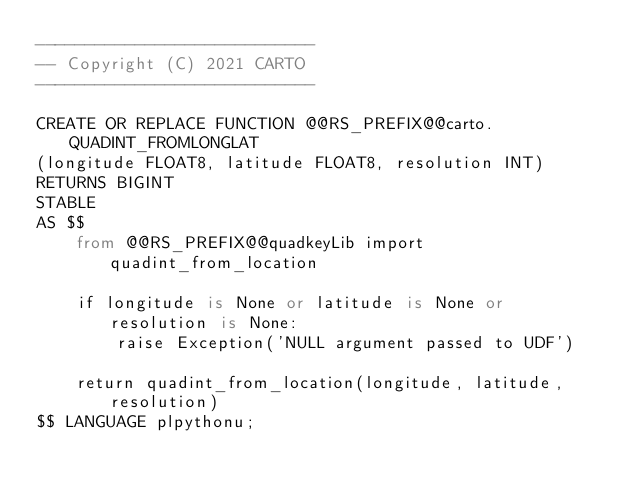<code> <loc_0><loc_0><loc_500><loc_500><_SQL_>----------------------------
-- Copyright (C) 2021 CARTO
----------------------------

CREATE OR REPLACE FUNCTION @@RS_PREFIX@@carto.QUADINT_FROMLONGLAT
(longitude FLOAT8, latitude FLOAT8, resolution INT)
RETURNS BIGINT
STABLE
AS $$
    from @@RS_PREFIX@@quadkeyLib import quadint_from_location
    
    if longitude is None or latitude is None or resolution is None:
        raise Exception('NULL argument passed to UDF')

    return quadint_from_location(longitude, latitude, resolution)
$$ LANGUAGE plpythonu;</code> 